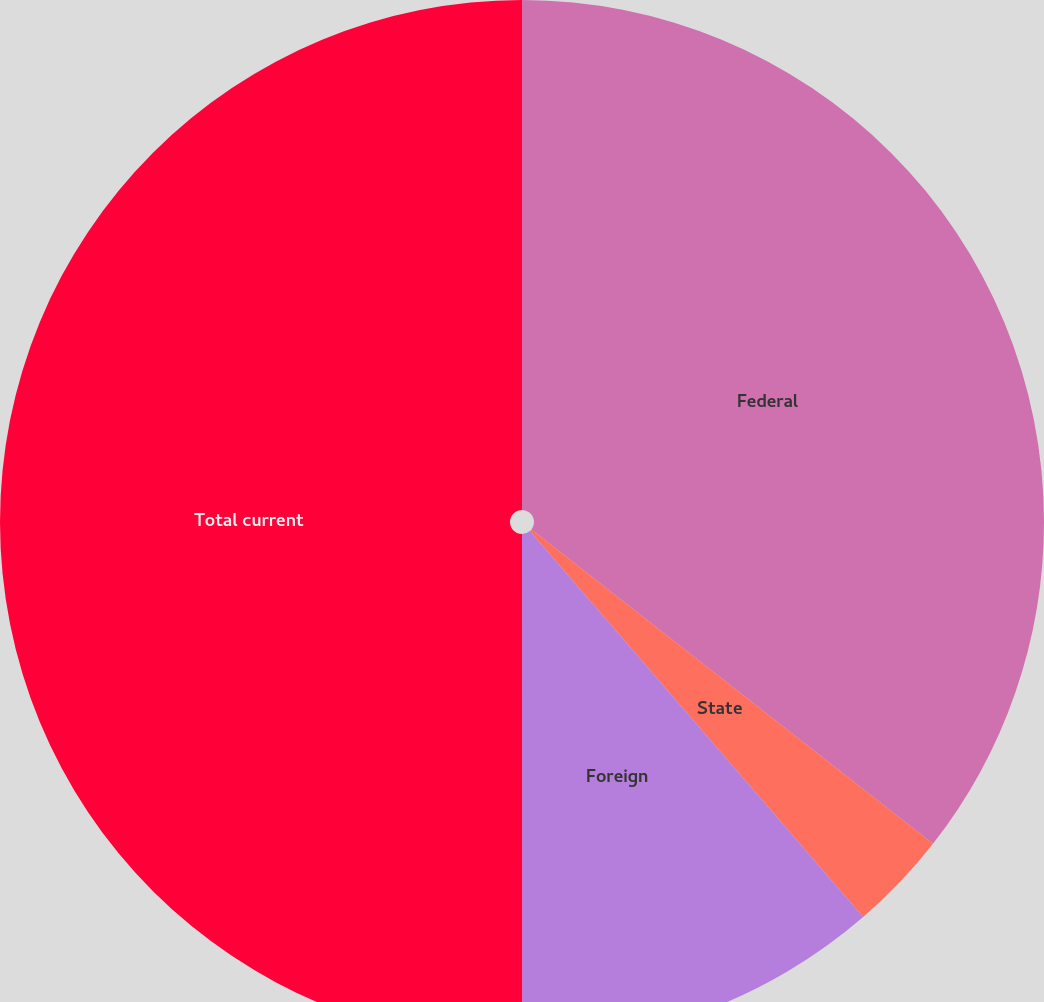Convert chart to OTSL. <chart><loc_0><loc_0><loc_500><loc_500><pie_chart><fcel>Federal<fcel>State<fcel>Foreign<fcel>Total current<nl><fcel>35.57%<fcel>3.09%<fcel>11.33%<fcel>50.0%<nl></chart> 